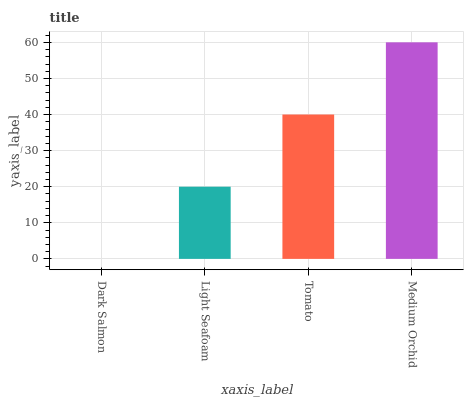Is Dark Salmon the minimum?
Answer yes or no. Yes. Is Medium Orchid the maximum?
Answer yes or no. Yes. Is Light Seafoam the minimum?
Answer yes or no. No. Is Light Seafoam the maximum?
Answer yes or no. No. Is Light Seafoam greater than Dark Salmon?
Answer yes or no. Yes. Is Dark Salmon less than Light Seafoam?
Answer yes or no. Yes. Is Dark Salmon greater than Light Seafoam?
Answer yes or no. No. Is Light Seafoam less than Dark Salmon?
Answer yes or no. No. Is Tomato the high median?
Answer yes or no. Yes. Is Light Seafoam the low median?
Answer yes or no. Yes. Is Dark Salmon the high median?
Answer yes or no. No. Is Tomato the low median?
Answer yes or no. No. 